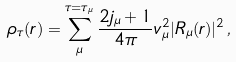Convert formula to latex. <formula><loc_0><loc_0><loc_500><loc_500>\rho _ { \tau } ( r ) = \sum ^ { \tau = \tau _ { \mu } } _ { \mu } \frac { 2 j _ { \mu } + 1 } { 4 \pi } v _ { \mu } ^ { 2 } | R _ { \mu } ( r ) | ^ { 2 } \, ,</formula> 